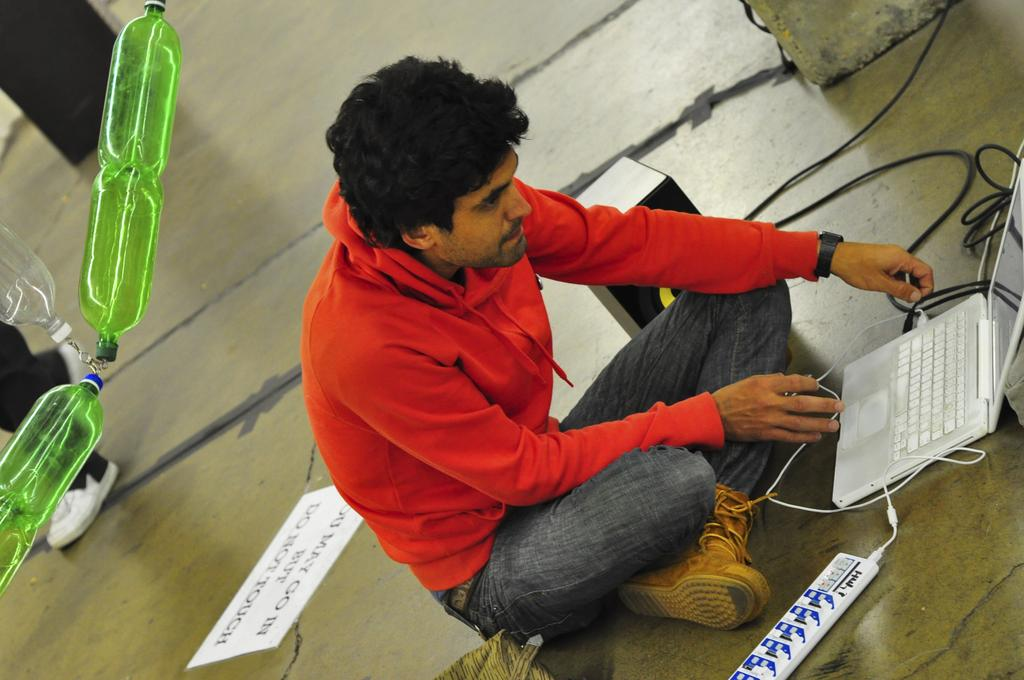What is the man in the image doing? The man is sitting on the floor in the image. What object is in front of the man? There is a laptop in front of the man. What can be seen on the left side of the image? There are bottles on the left side of the image. What is on the floor near the man? There is a paper on the floor in the image. What else is visible in the image? Wires are visible in the image. What language is the man speaking in the image? The image does not provide any information about the language being spoken, as it is a silent medium. Can you see a donkey in the image? No, there is no donkey present in the image. 